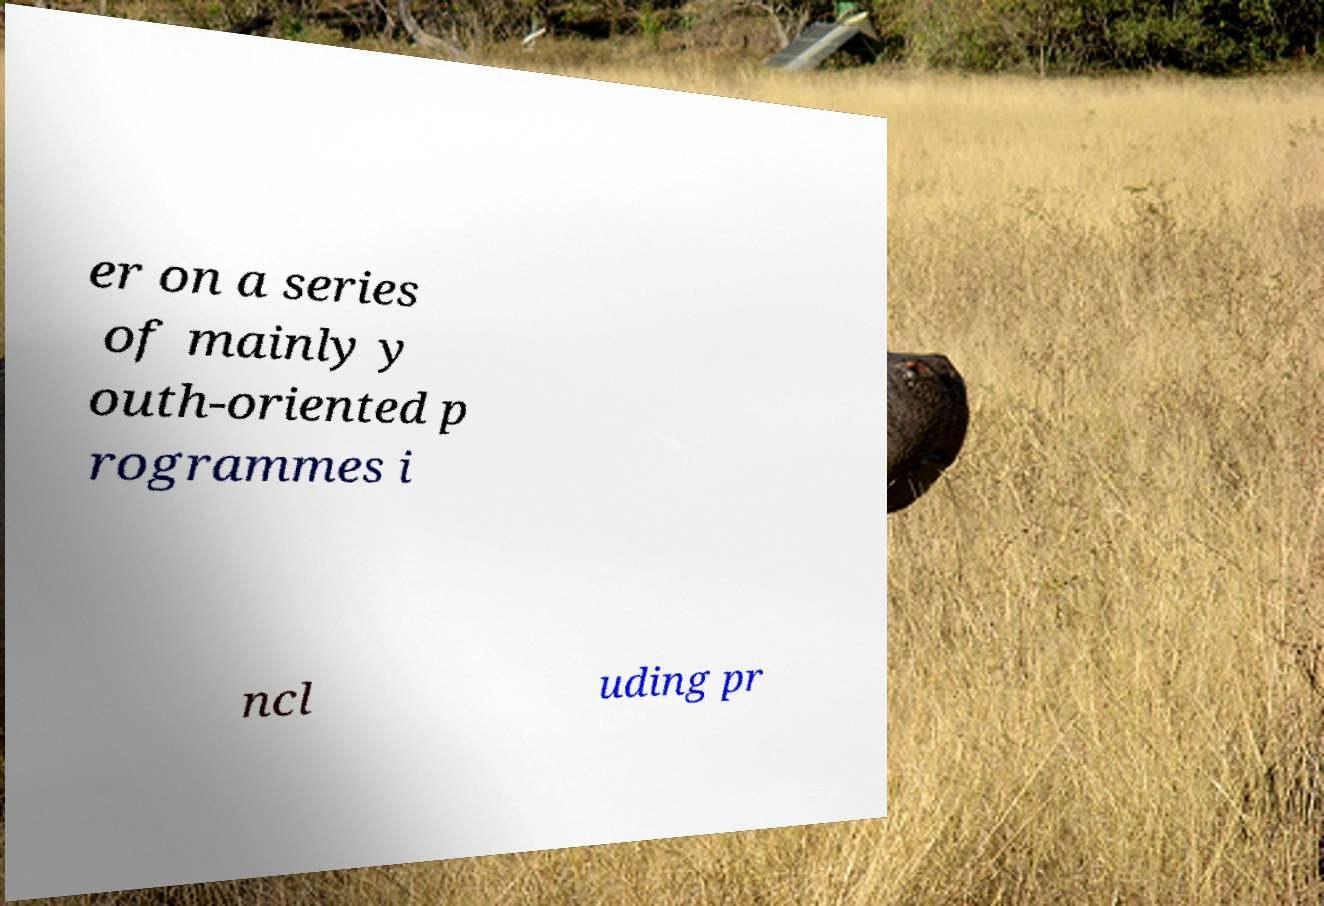Can you read and provide the text displayed in the image?This photo seems to have some interesting text. Can you extract and type it out for me? er on a series of mainly y outh-oriented p rogrammes i ncl uding pr 